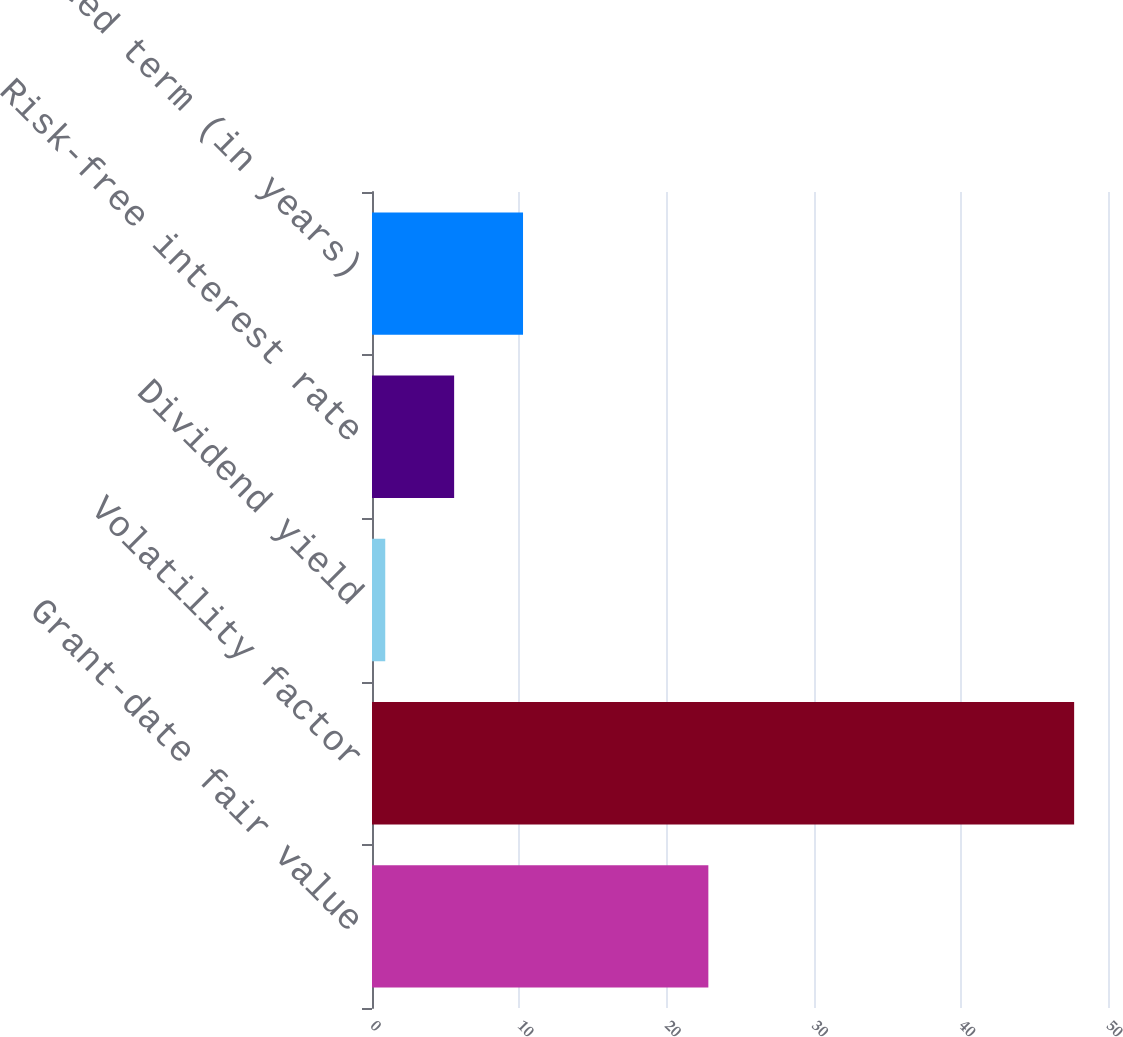<chart> <loc_0><loc_0><loc_500><loc_500><bar_chart><fcel>Grant-date fair value<fcel>Volatility factor<fcel>Dividend yield<fcel>Risk-free interest rate<fcel>Expected term (in years)<nl><fcel>22.85<fcel>47.7<fcel>0.9<fcel>5.58<fcel>10.26<nl></chart> 